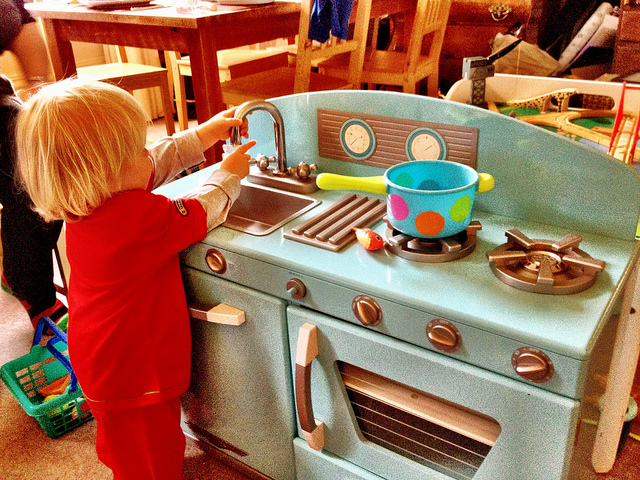What might this child learn from playing with this toy? Through playing with this kitchen set, the child may learn valuable life skills such as cooking basics, kitchen safety, and the importance of cleanliness. Additionally, it encourages the development of fine motor skills, cognitive abilities, and imaginative play, which are crucial during early childhood. 